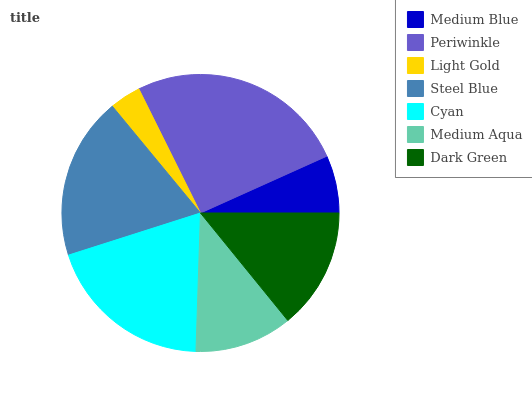Is Light Gold the minimum?
Answer yes or no. Yes. Is Periwinkle the maximum?
Answer yes or no. Yes. Is Periwinkle the minimum?
Answer yes or no. No. Is Light Gold the maximum?
Answer yes or no. No. Is Periwinkle greater than Light Gold?
Answer yes or no. Yes. Is Light Gold less than Periwinkle?
Answer yes or no. Yes. Is Light Gold greater than Periwinkle?
Answer yes or no. No. Is Periwinkle less than Light Gold?
Answer yes or no. No. Is Dark Green the high median?
Answer yes or no. Yes. Is Dark Green the low median?
Answer yes or no. Yes. Is Light Gold the high median?
Answer yes or no. No. Is Periwinkle the low median?
Answer yes or no. No. 